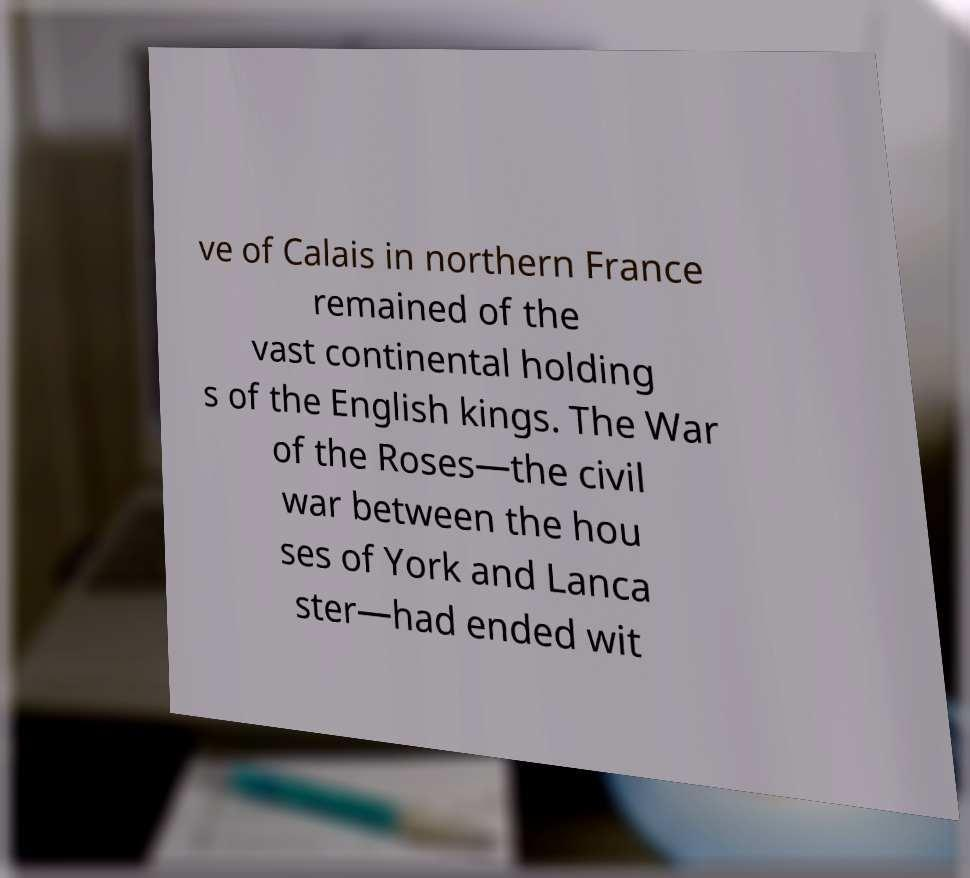Can you accurately transcribe the text from the provided image for me? ve of Calais in northern France remained of the vast continental holding s of the English kings. The War of the Roses—the civil war between the hou ses of York and Lanca ster—had ended wit 